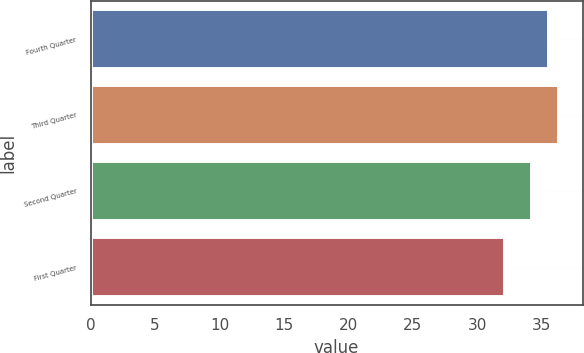Convert chart to OTSL. <chart><loc_0><loc_0><loc_500><loc_500><bar_chart><fcel>Fourth Quarter<fcel>Third Quarter<fcel>Second Quarter<fcel>First Quarter<nl><fcel>35.58<fcel>36.35<fcel>34.26<fcel>32.12<nl></chart> 